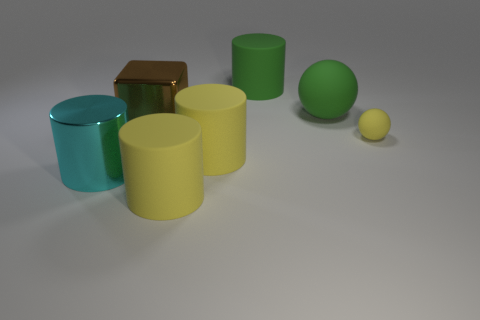What size is the thing that is the same color as the large ball?
Your response must be concise. Large. There is a big metal thing behind the large cyan thing; what is its color?
Your answer should be very brief. Brown. What shape is the rubber thing that is the same color as the big sphere?
Keep it short and to the point. Cylinder. The metal object in front of the small rubber sphere has what shape?
Provide a succinct answer. Cylinder. How many cyan things are large cubes or small balls?
Keep it short and to the point. 0. Do the big block and the cyan thing have the same material?
Your answer should be very brief. Yes. There is a block; how many large cylinders are to the left of it?
Give a very brief answer. 1. There is a yellow thing that is to the left of the small yellow rubber object and behind the cyan metal thing; what material is it made of?
Your response must be concise. Rubber. How many spheres are large green things or large yellow objects?
Offer a terse response. 1. What material is the large green object that is the same shape as the cyan thing?
Offer a terse response. Rubber. 